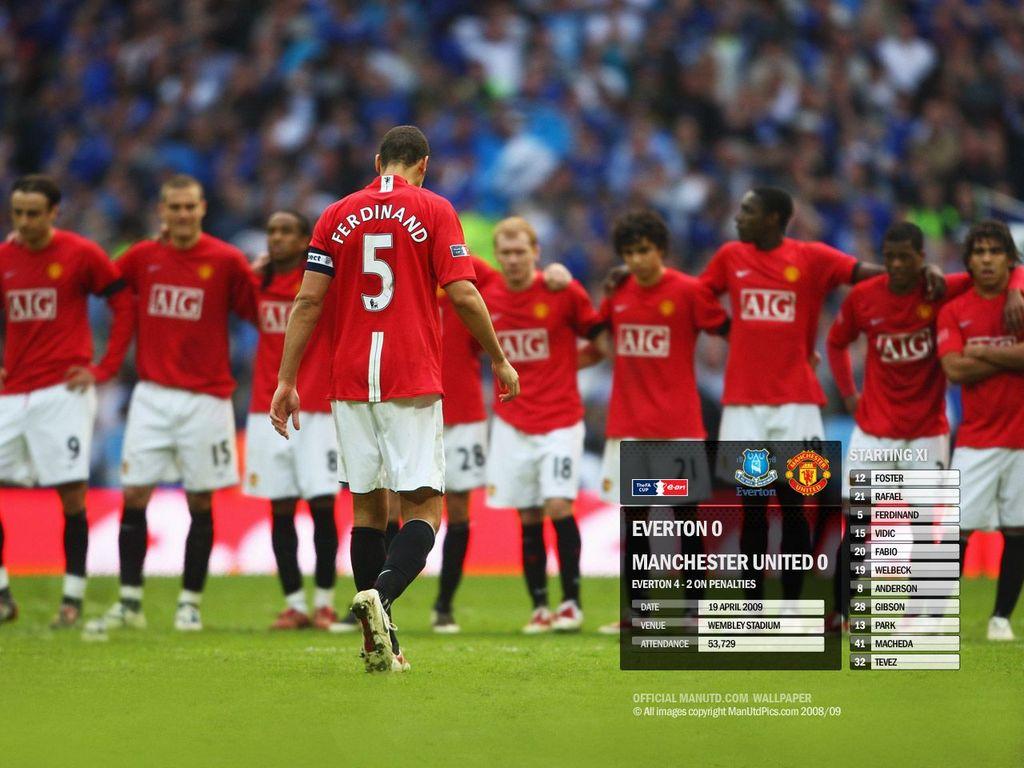What soccer team is on the picture?
Make the answer very short. Aig. According to the infographic, what is the venue for this match?
Make the answer very short. Unanswerable. 